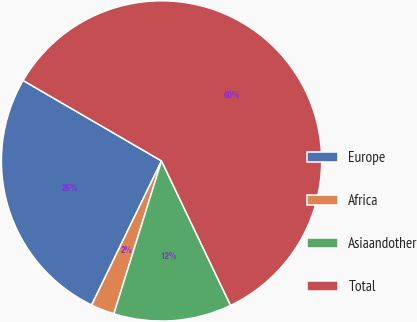Convert chart. <chart><loc_0><loc_0><loc_500><loc_500><pie_chart><fcel>Europe<fcel>Africa<fcel>Asiaandother<fcel>Total<nl><fcel>26.19%<fcel>2.38%<fcel>11.9%<fcel>59.52%<nl></chart> 